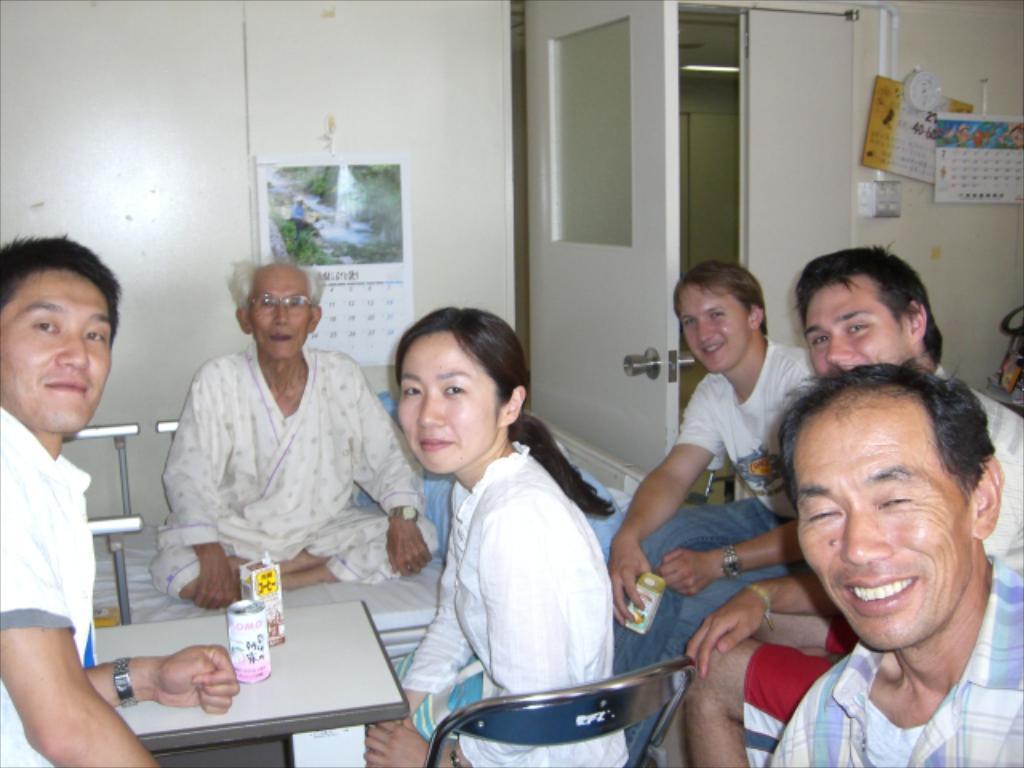Can you describe this image briefly? Here in this picture in the front we can see a group of people sitting on chairs present over there and we can also see a table present over there, on which we can see a couple of tins present over there and behind them we can see an old man sitting on a bed over there and we can also see a door present over there and we can see a calendar present on the wall over there and we can see all them are smiling. 